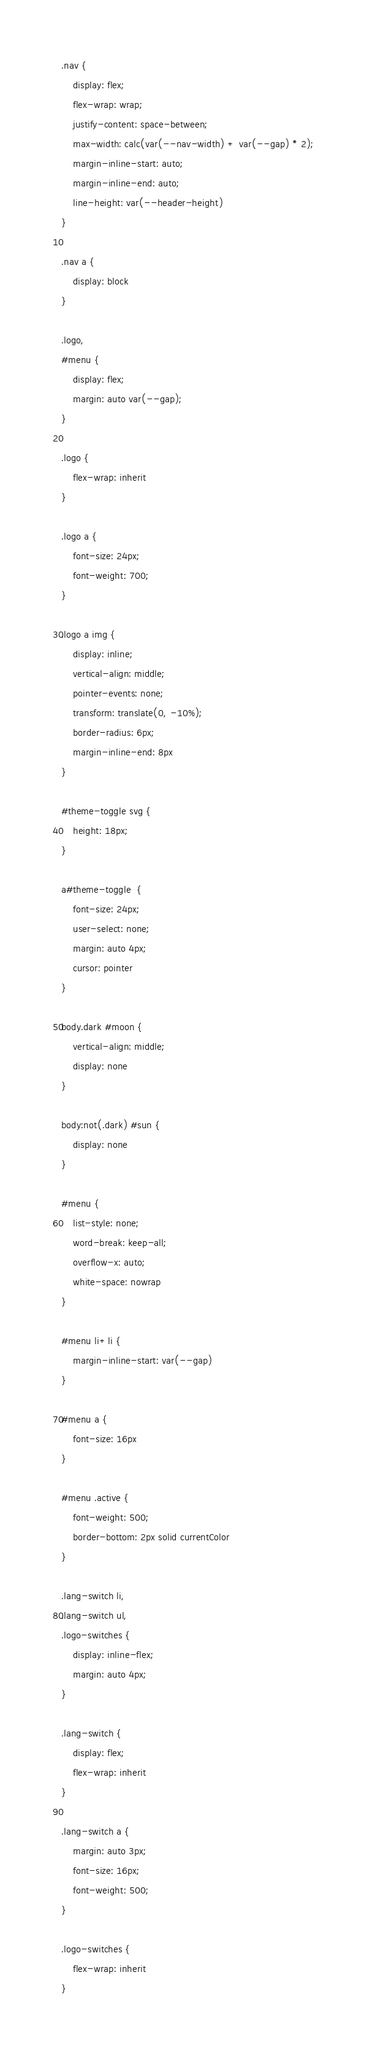<code> <loc_0><loc_0><loc_500><loc_500><_CSS_>.nav {
    display: flex;
    flex-wrap: wrap;
    justify-content: space-between;
    max-width: calc(var(--nav-width) + var(--gap) * 2);
    margin-inline-start: auto;
    margin-inline-end: auto;
    line-height: var(--header-height)
}

.nav a {
    display: block
}

.logo,
#menu {
    display: flex;
    margin: auto var(--gap);
}

.logo {
    flex-wrap: inherit
}

.logo a {
    font-size: 24px;
    font-weight: 700;
}

.logo a img {
    display: inline;
    vertical-align: middle;
    pointer-events: none;
    transform: translate(0, -10%);
    border-radius: 6px;
    margin-inline-end: 8px
}

#theme-toggle svg {
    height: 18px;
}

a#theme-toggle  {
    font-size: 24px;
    user-select: none;
    margin: auto 4px;
    cursor: pointer
}

body.dark #moon {
    vertical-align: middle;
    display: none
}

body:not(.dark) #sun {
    display: none
}

#menu {
    list-style: none;
    word-break: keep-all;
    overflow-x: auto;
    white-space: nowrap
}

#menu li+li {
    margin-inline-start: var(--gap)
}

#menu a {
    font-size: 16px
}

#menu .active {
    font-weight: 500;
    border-bottom: 2px solid currentColor
}

.lang-switch li,
.lang-switch ul,
.logo-switches {
    display: inline-flex;
    margin: auto 4px;
}

.lang-switch {
    display: flex;
    flex-wrap: inherit
}

.lang-switch a {
    margin: auto 3px;
    font-size: 16px;
    font-weight: 500;
}

.logo-switches {
    flex-wrap: inherit
}
</code> 